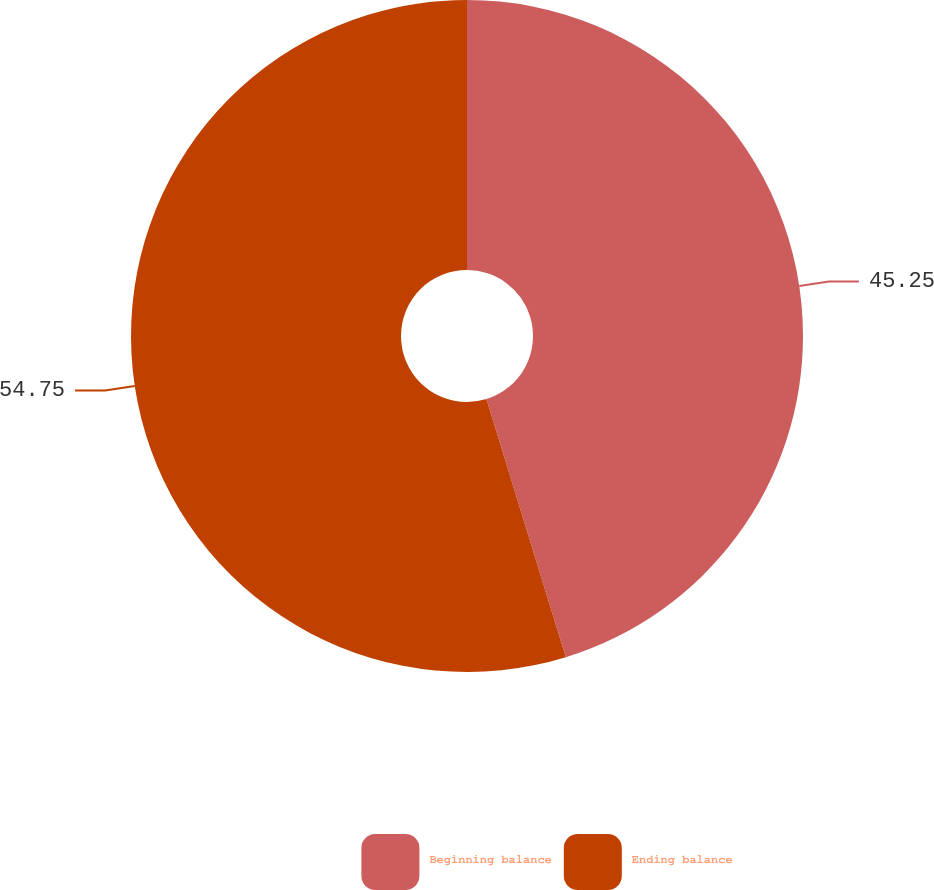Convert chart to OTSL. <chart><loc_0><loc_0><loc_500><loc_500><pie_chart><fcel>Beginning balance<fcel>Ending balance<nl><fcel>45.25%<fcel>54.75%<nl></chart> 